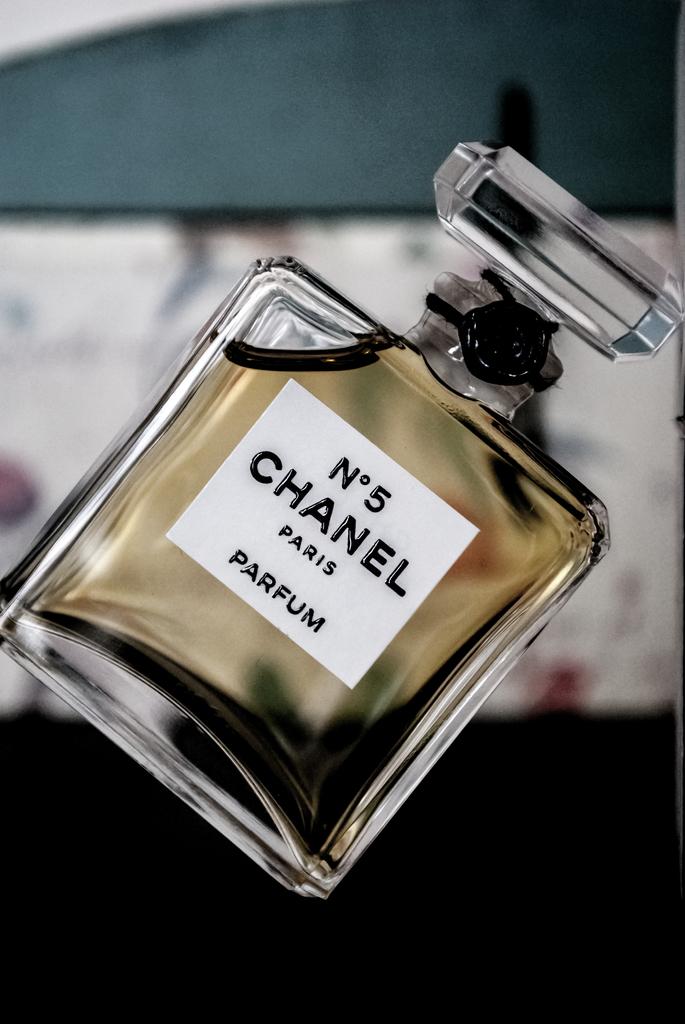What is the name of the perfume?
Your answer should be very brief. Chanel. What is in the bottle?
Provide a short and direct response. Parfum. 